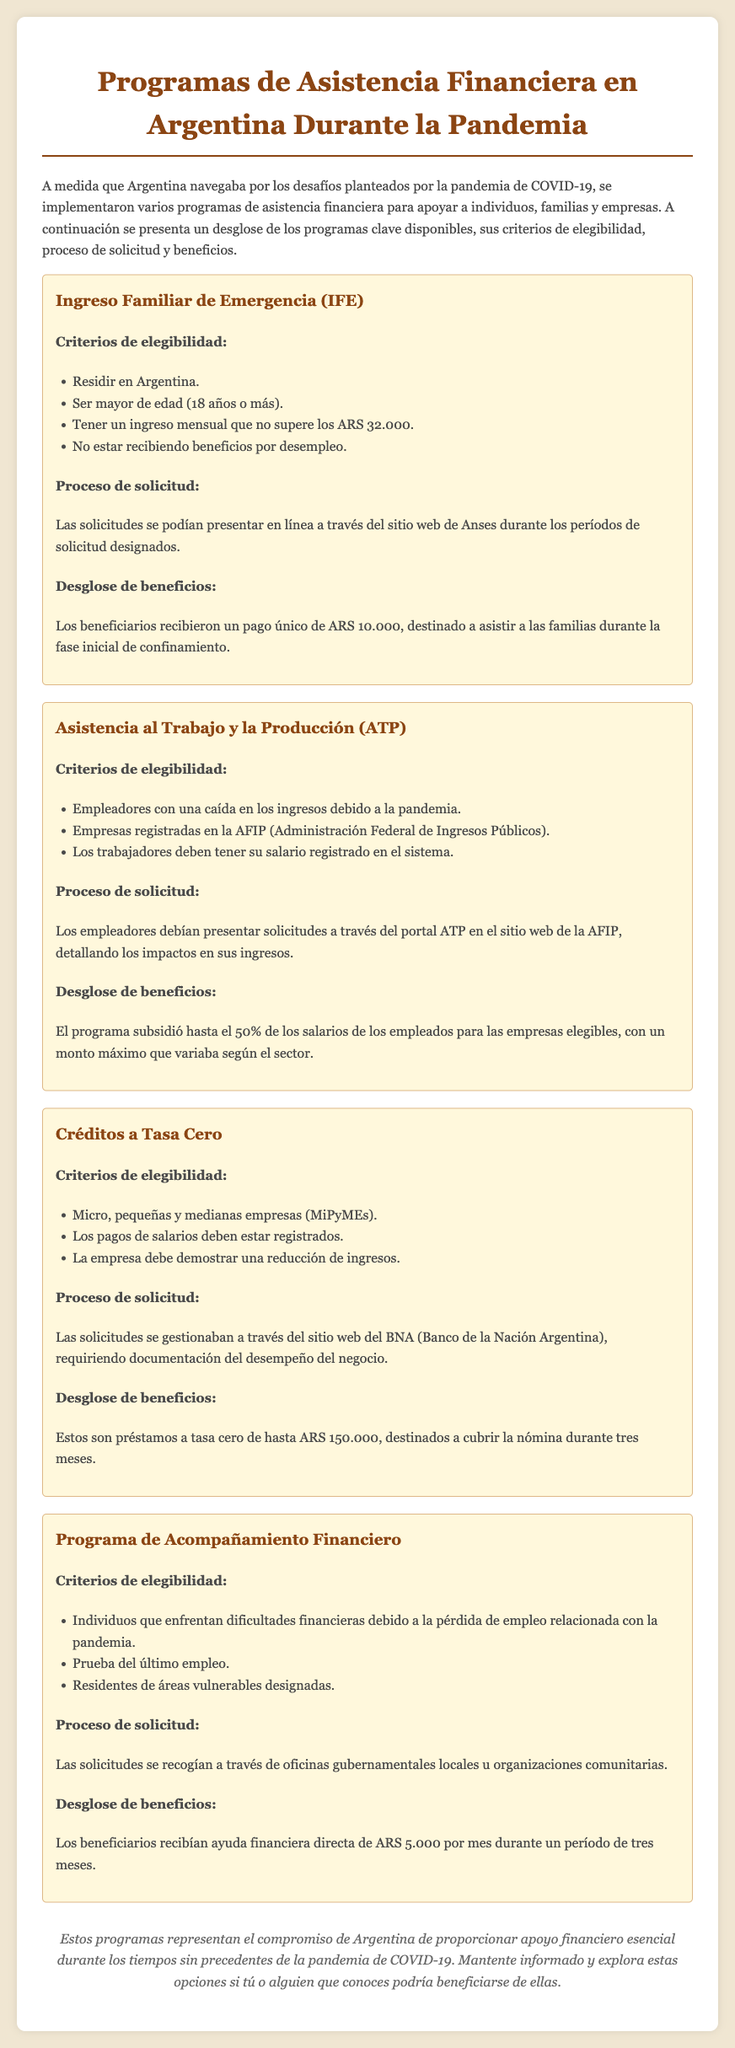¿Qué es el IFE? El IFE es uno de los programas de asistencia financiera implementados en Argentina durante la pandemia, cuyo objetivo es apoyar a las familias.
Answer: Ingreso Familiar de Emergencia (IFE) ¿Cuál es el monto del IFE? El monto que los beneficiarios reciben por el IFE es un pago único para ayudar a las familias en la pandemia.
Answer: ARS 10.000 ¿Quiénes pueden aplicar al programa ATP? Los empleadores con una caída en los ingresos debido a la pandemia pueden aplicar al ATP.
Answer: Empleadores con caída en los ingresos ¿Cuál es el subsidio máximo del ATP? El ATP subsidia un porcentaje de los salarios de los empleados para las empresas elegibles, con variaciones según el sector.
Answer: Hasta el 50% ¿Qué tipo de empresas son elegibles para los Créditos a Tasa Cero? Esta asistencia está dirigida a una categoría específica de empresas que se ven afectadas económicamente.
Answer: Micro, pequeñas y medianas empresas (MiPyMEs) ¿Cuánto es la ayuda financiera mensual del Programa de Acompañamiento Financiero? Este programa proporciona un apoyo específico para personas que han perdido su empleo.
Answer: ARS 5.000 ¿Cuál es el proceso de solicitud del IFE? Las solicitudes del IFE deben hacerse mediante una plataforma en línea durante ciertos períodos de tiempo.
Answer: Sitio web de Anses ¿Cuánto tiempo dura la asistencia del Programa de Acompañamiento Financiero? Este programa proporciona ayuda durante un período limitado en función de las regulaciones establecidas.
Answer: Tres meses ¿Cuál es el requisito más importante para acceder al Programa de Acompañamiento Financiero? Existe un criterio crítico relacionado con la situación laboral de los solicitantes.
Answer: Prueba del último empleo 